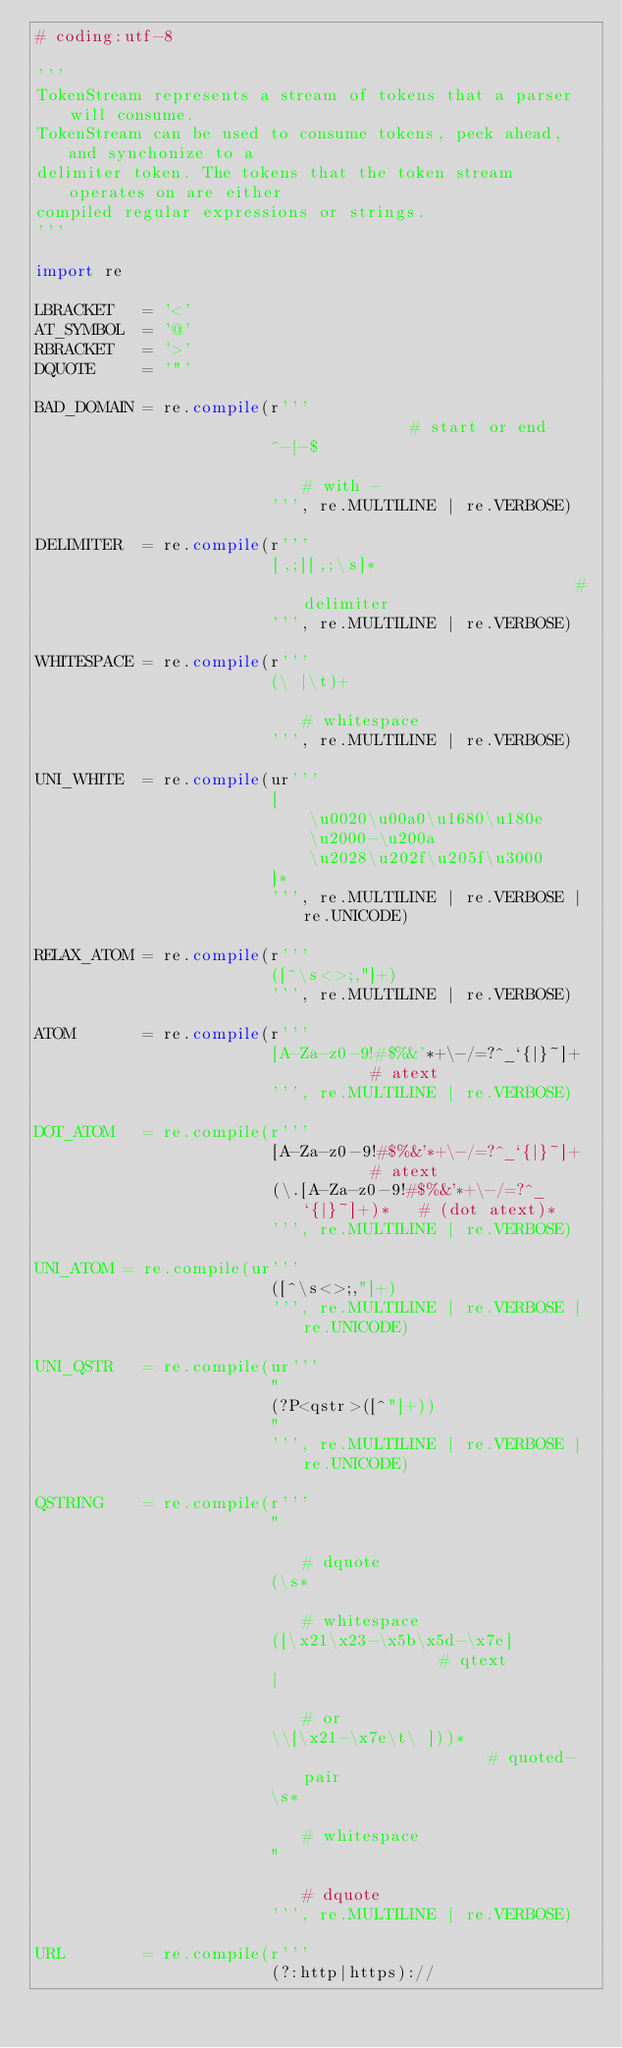<code> <loc_0><loc_0><loc_500><loc_500><_Python_># coding:utf-8

'''
TokenStream represents a stream of tokens that a parser will consume.
TokenStream can be used to consume tokens, peek ahead, and synchonize to a
delimiter token. The tokens that the token stream operates on are either
compiled regular expressions or strings.
'''

import re

LBRACKET   = '<'
AT_SYMBOL  = '@'
RBRACKET   = '>'
DQUOTE     = '"'

BAD_DOMAIN = re.compile(r'''                                    # start or end
                        ^-|-$                                   # with -
                        ''', re.MULTILINE | re.VERBOSE)

DELIMITER  = re.compile(r'''
                        [,;][,;\s]*                             # delimiter
                        ''', re.MULTILINE | re.VERBOSE)

WHITESPACE = re.compile(r'''
                        (\ |\t)+                                # whitespace
                        ''', re.MULTILINE | re.VERBOSE)

UNI_WHITE  = re.compile(ur'''
                        [
                            \u0020\u00a0\u1680\u180e
                            \u2000-\u200a
                            \u2028\u202f\u205f\u3000
                        ]*
                        ''', re.MULTILINE | re.VERBOSE | re.UNICODE)

RELAX_ATOM = re.compile(r'''
                        ([^\s<>;,"]+)
                        ''', re.MULTILINE | re.VERBOSE)

ATOM       = re.compile(r'''
                        [A-Za-z0-9!#$%&'*+\-/=?^_`{|}~]+        # atext
                        ''', re.MULTILINE | re.VERBOSE)

DOT_ATOM   = re.compile(r'''
                        [A-Za-z0-9!#$%&'*+\-/=?^_`{|}~]+        # atext
                        (\.[A-Za-z0-9!#$%&'*+\-/=?^_`{|}~]+)*   # (dot atext)*
                        ''', re.MULTILINE | re.VERBOSE)

UNI_ATOM = re.compile(ur'''
                        ([^\s<>;,"]+)
                        ''', re.MULTILINE | re.VERBOSE | re.UNICODE)

UNI_QSTR   = re.compile(ur'''
                        "
                        (?P<qstr>([^"]+))
                        "
                        ''', re.MULTILINE | re.VERBOSE | re.UNICODE)

QSTRING    = re.compile(r'''
                        "                                       # dquote
                        (\s*                                    # whitespace
                        ([\x21\x23-\x5b\x5d-\x7e]               # qtext
                        |                                       # or
                        \\[\x21-\x7e\t\ ]))*                    # quoted-pair
                        \s*                                     # whitespace
                        "                                       # dquote
                        ''', re.MULTILINE | re.VERBOSE)

URL        = re.compile(r'''
                        (?:http|https)://</code> 